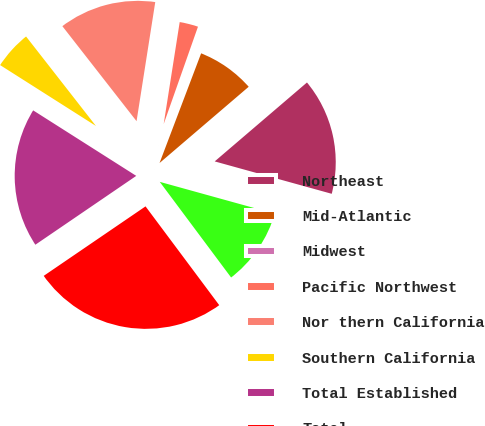Convert chart. <chart><loc_0><loc_0><loc_500><loc_500><pie_chart><fcel>Northeast<fcel>Mid-Atlantic<fcel>Midwest<fcel>Pacific Northwest<fcel>Nor thern California<fcel>Southern California<fcel>Total Established<fcel>Total<fcel>Northern California<nl><fcel>15.56%<fcel>7.97%<fcel>0.38%<fcel>2.91%<fcel>13.03%<fcel>5.44%<fcel>18.54%<fcel>25.67%<fcel>10.5%<nl></chart> 